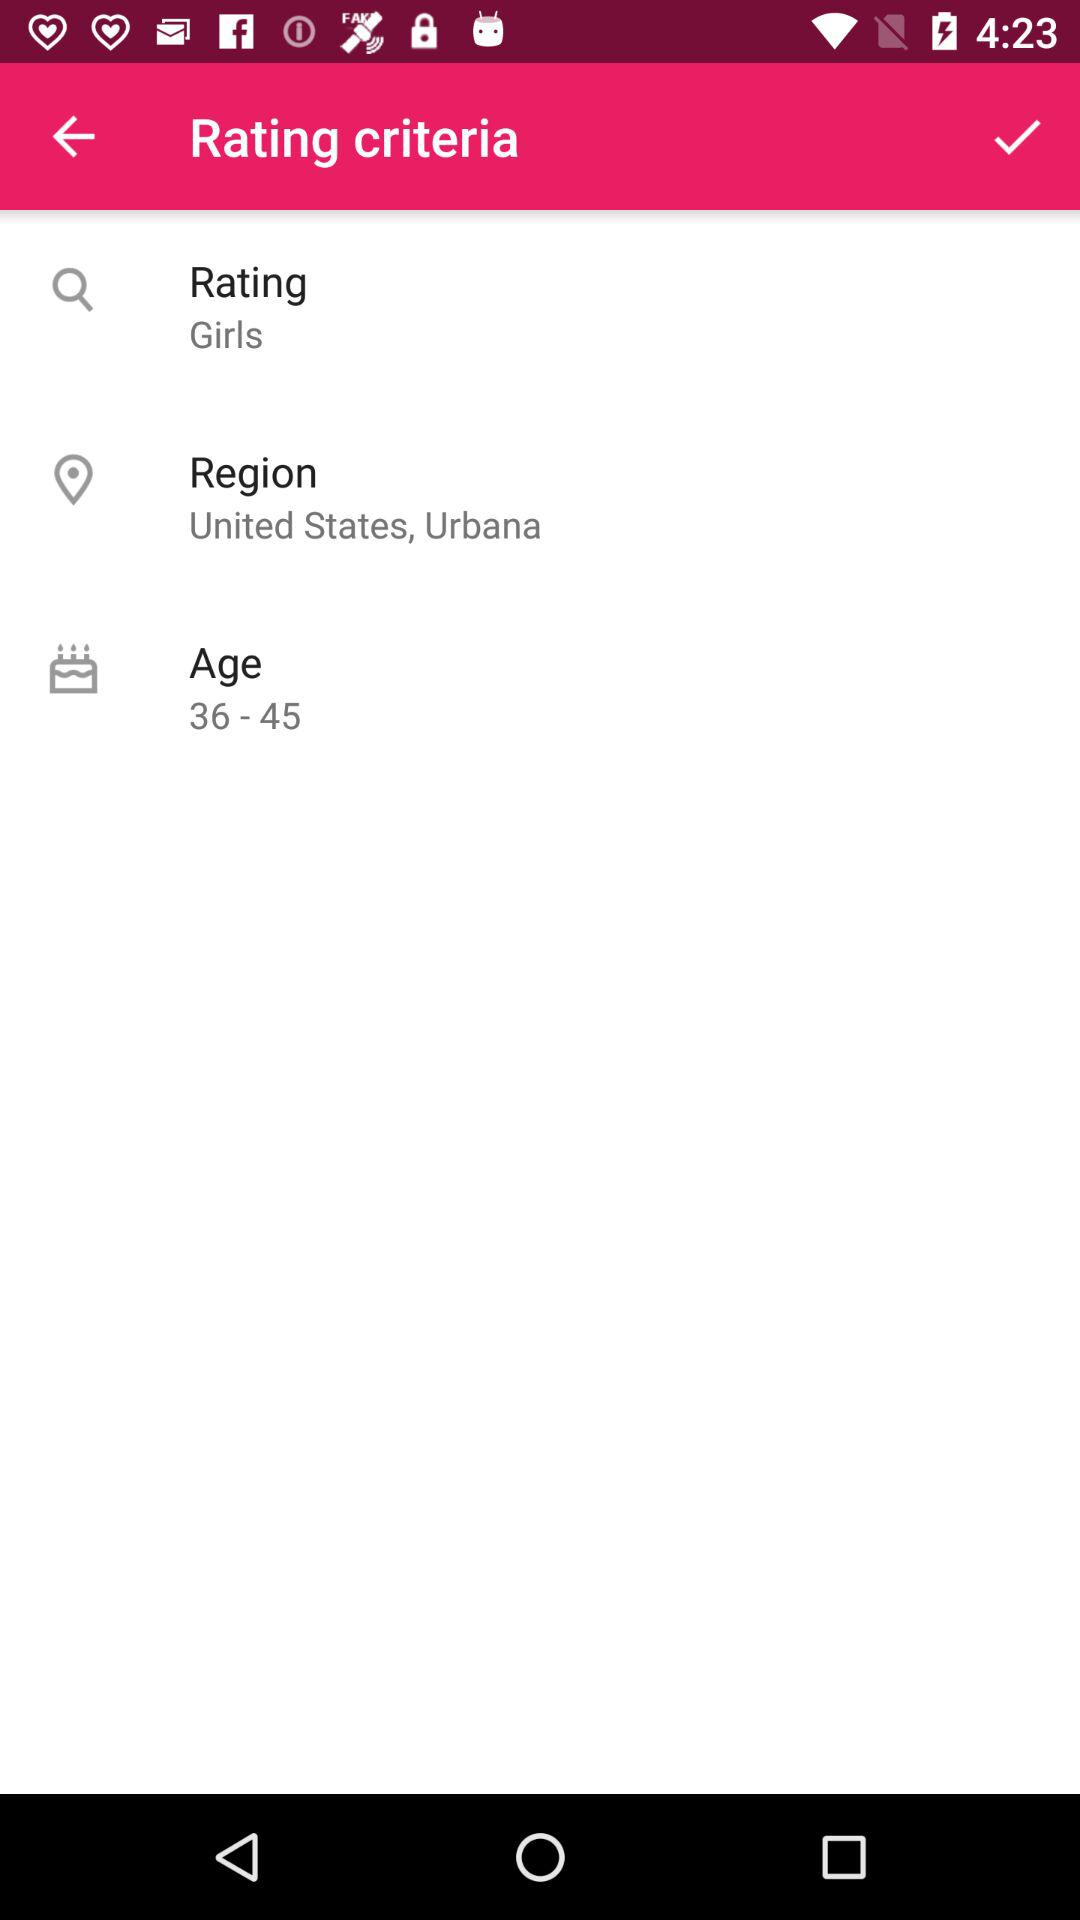How many rating criteria are there? The image shows that there are three rating criteria listed: 'Rating Girls,' 'Region' with the subtext 'United States, Urbana,' and 'Age' with the range '36 - 45.' 